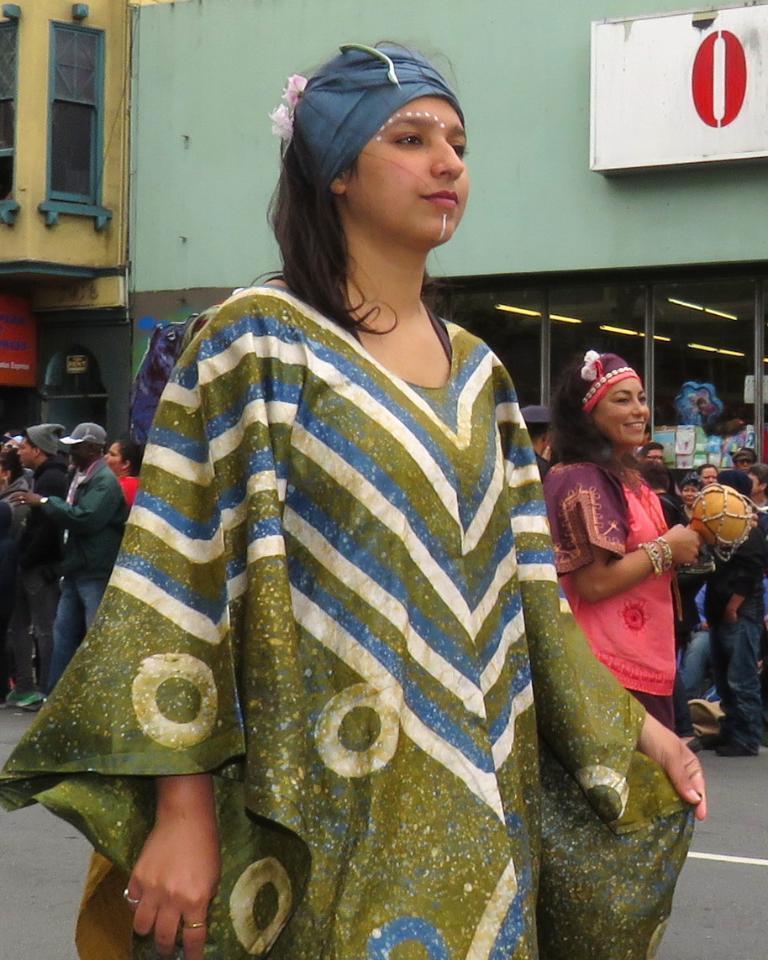Could you give a brief overview of what you see in this image? In this image we can see there are a few people standing on the road. In the background there are buildings. 